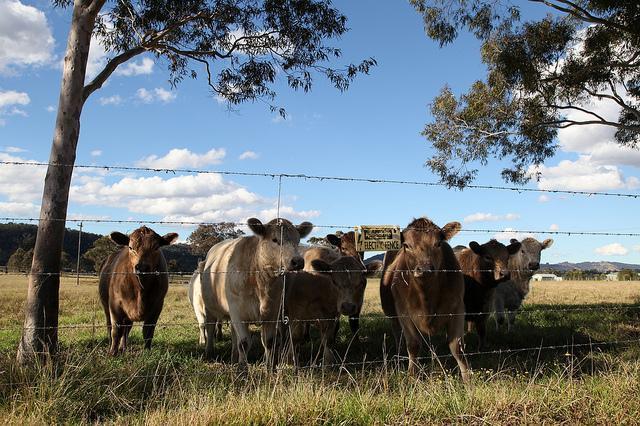How many trees?
Give a very brief answer. 2. How many cows are there?
Give a very brief answer. 6. How many people are wearing red shirt?
Give a very brief answer. 0. 